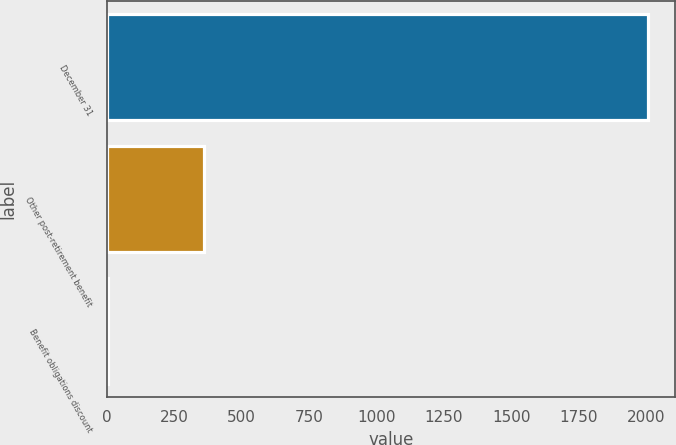<chart> <loc_0><loc_0><loc_500><loc_500><bar_chart><fcel>December 31<fcel>Other post-retirement benefit<fcel>Benefit obligations discount<nl><fcel>2007<fcel>362.9<fcel>6.2<nl></chart> 